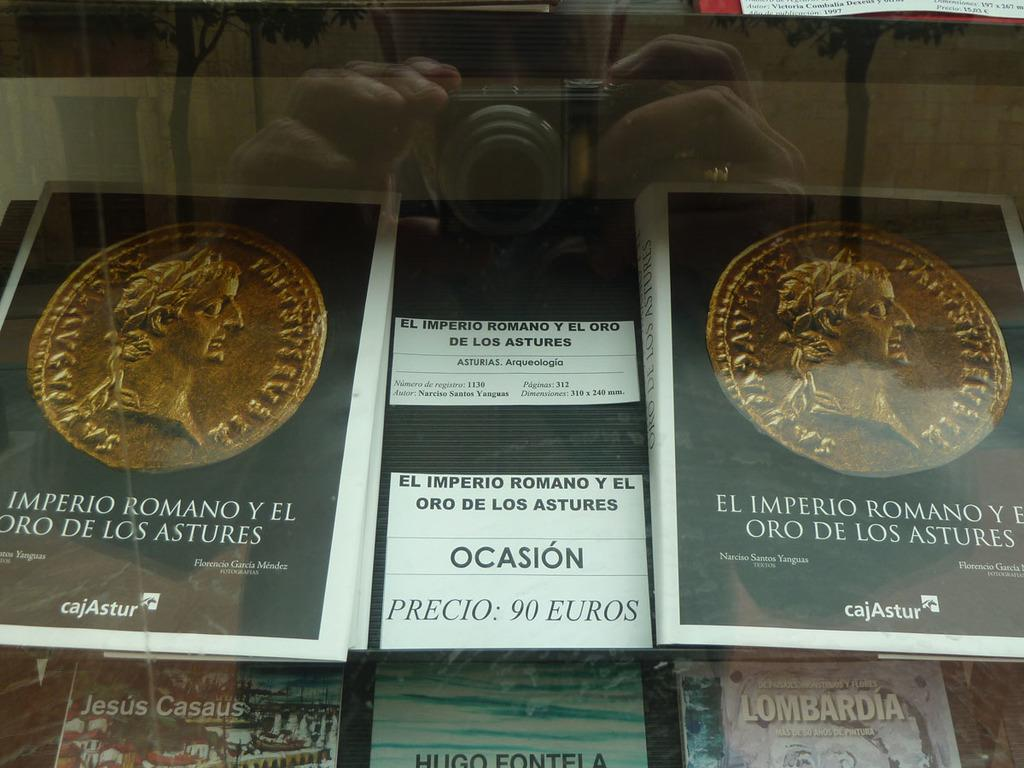What objects are inside the glass in the foreground of the image? There are books inside a glass in the foreground of the image. Can you describe the man's activity in the image? The man is holding a camera, as seen in the reflection of the image. What type of wax can be seen melting in the image? There is no wax present in the image. Where is the basin located in the image? There is no basin present in the image. 